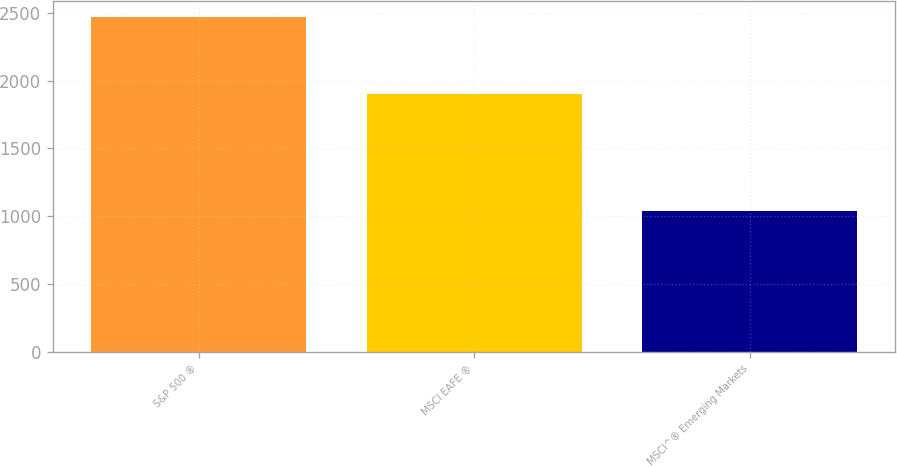<chart> <loc_0><loc_0><loc_500><loc_500><bar_chart><fcel>S&P 500 ®<fcel>MSCI EAFE ®<fcel>MSCI^® Emerging Markets<nl><fcel>2465<fcel>1900<fcel>1036<nl></chart> 